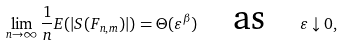Convert formula to latex. <formula><loc_0><loc_0><loc_500><loc_500>\lim _ { n \to \infty } \frac { 1 } { n } E ( | S ( F _ { n , m } ) | ) = \Theta ( \varepsilon ^ { \beta } ) \quad \text {as} \quad \varepsilon \downarrow 0 ,</formula> 